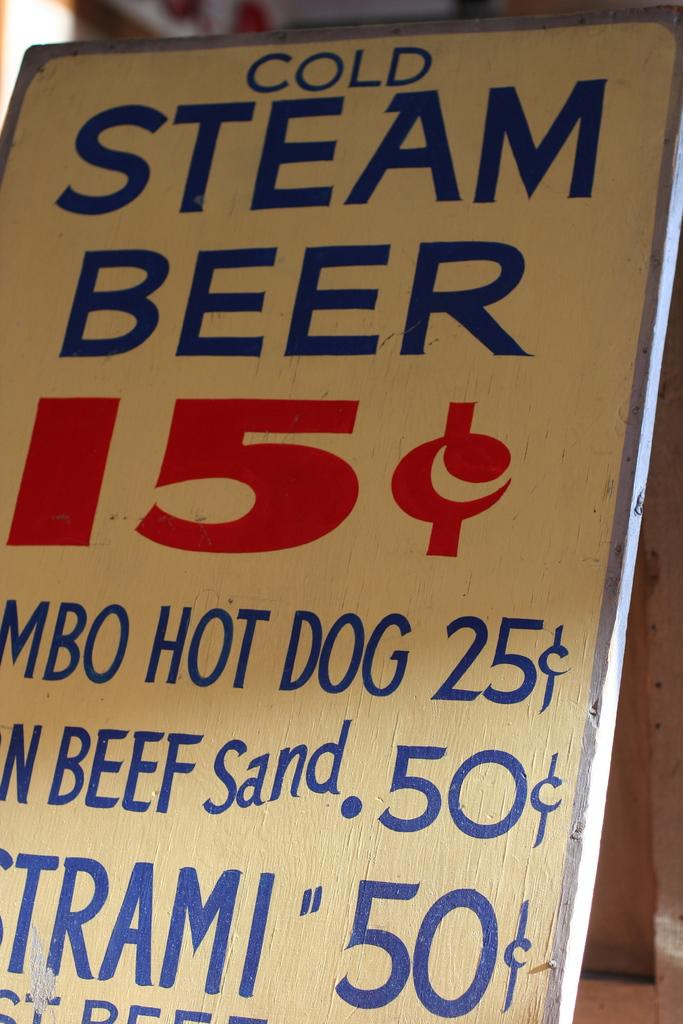<image>
Give a short and clear explanation of the subsequent image. A sign advertising 15c and other cheap food. 